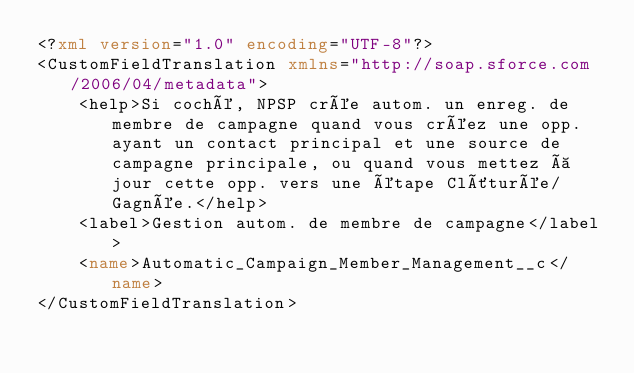Convert code to text. <code><loc_0><loc_0><loc_500><loc_500><_XML_><?xml version="1.0" encoding="UTF-8"?>
<CustomFieldTranslation xmlns="http://soap.sforce.com/2006/04/metadata">
    <help>Si coché, NPSP crée autom. un enreg. de membre de campagne quand vous créez une opp. ayant un contact principal et une source de campagne principale, ou quand vous mettez à jour cette opp. vers une étape Clôturée/Gagnée.</help>
    <label>Gestion autom. de membre de campagne</label>
    <name>Automatic_Campaign_Member_Management__c</name>
</CustomFieldTranslation>
</code> 